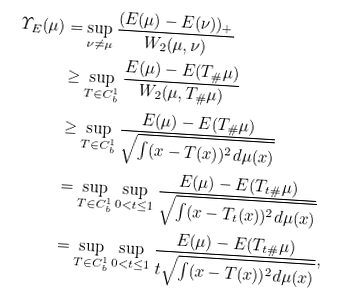<formula> <loc_0><loc_0><loc_500><loc_500>\varUpsilon _ { E } ( \mu ) & = \sup _ { \nu \neq \mu } \frac { ( E ( \mu ) - E ( \nu ) ) _ { + } } { W _ { 2 } ( \mu , \nu ) } \\ & \geq \sup _ { T \in C ^ { 1 } _ { b } } \frac { E ( \mu ) - E ( T _ { \# } \mu ) } { W _ { 2 } ( \mu , T _ { \# } \mu ) } \\ & \geq \sup _ { T \in C ^ { 1 } _ { b } } \frac { E ( \mu ) - E ( T _ { \# } \mu ) } { \sqrt { \int ( x - T ( x ) ) ^ { 2 } d \mu ( x ) } } \\ & = \sup _ { T \in C ^ { 1 } _ { b } } \sup _ { 0 < t \leq 1 } \frac { E ( \mu ) - E ( T _ { t \# } \mu ) } { \sqrt { \int ( x - T _ { t } ( x ) ) ^ { 2 } d \mu ( x ) } } \\ & = \sup _ { T \in C ^ { 1 } _ { b } } \sup _ { 0 < t \leq 1 } \frac { E ( \mu ) - E ( T _ { t \# } \mu ) } { t \sqrt { \int ( x - T ( x ) ) ^ { 2 } d \mu ( x ) } } ,</formula> 